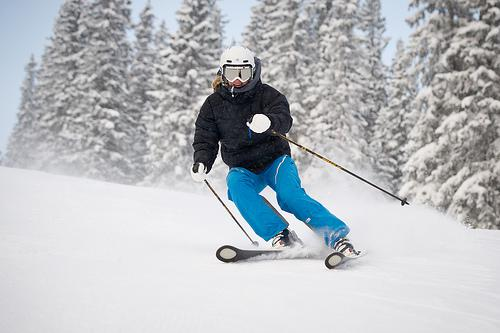Question: who is wearing blue pants?
Choices:
A. The skateboarder.
B. The old woman.
C. LIttle Richie.
D. A skier.
Answer with the letter. Answer: D Question: why is there a cloud of snow around the skier?
Choices:
A. Wind.
B. Avalanche.
C. Snow mobile.
D. The skier is kicking up.
Answer with the letter. Answer: D 